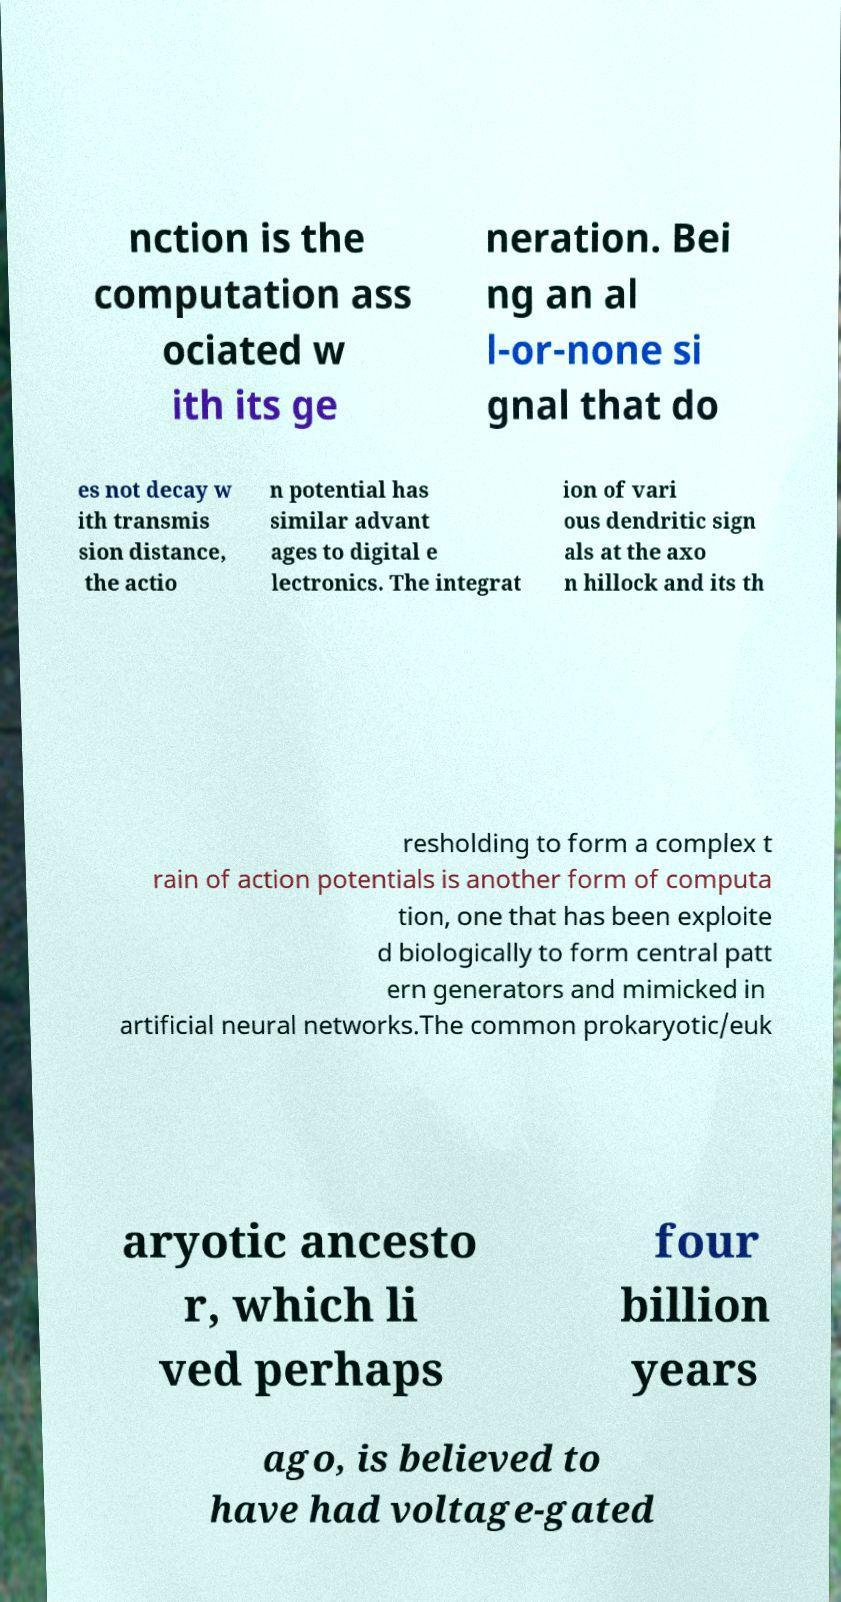For documentation purposes, I need the text within this image transcribed. Could you provide that? nction is the computation ass ociated w ith its ge neration. Bei ng an al l-or-none si gnal that do es not decay w ith transmis sion distance, the actio n potential has similar advant ages to digital e lectronics. The integrat ion of vari ous dendritic sign als at the axo n hillock and its th resholding to form a complex t rain of action potentials is another form of computa tion, one that has been exploite d biologically to form central patt ern generators and mimicked in artificial neural networks.The common prokaryotic/euk aryotic ancesto r, which li ved perhaps four billion years ago, is believed to have had voltage-gated 